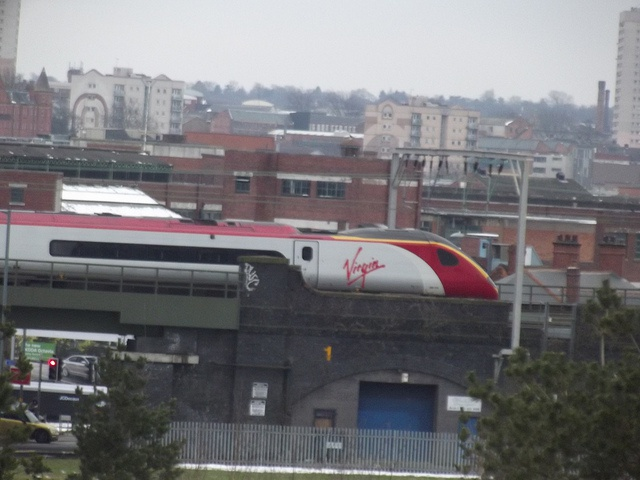Describe the objects in this image and their specific colors. I can see train in gray, darkgray, black, and brown tones, bus in gray, black, lightgray, and darkgray tones, car in gray, black, darkgreen, and darkgray tones, car in gray, black, and darkgray tones, and traffic light in gray, black, purple, and brown tones in this image. 